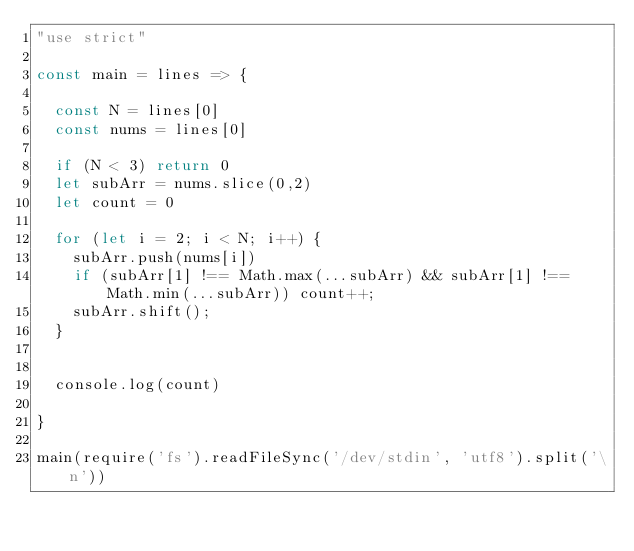<code> <loc_0><loc_0><loc_500><loc_500><_JavaScript_>"use strict"
 
const main = lines => {
 
  const N = lines[0]
  const nums = lines[0]

  if (N < 3) return 0
  let subArr = nums.slice(0,2)
  let count = 0
  
  for (let i = 2; i < N; i++) {
    subArr.push(nums[i])
    if (subArr[1] !== Math.max(...subArr) && subArr[1] !== Math.min(...subArr)) count++;
    subArr.shift();
  }
  
  
  console.log(count)
 
}
  
main(require('fs').readFileSync('/dev/stdin', 'utf8').split('\n'))</code> 